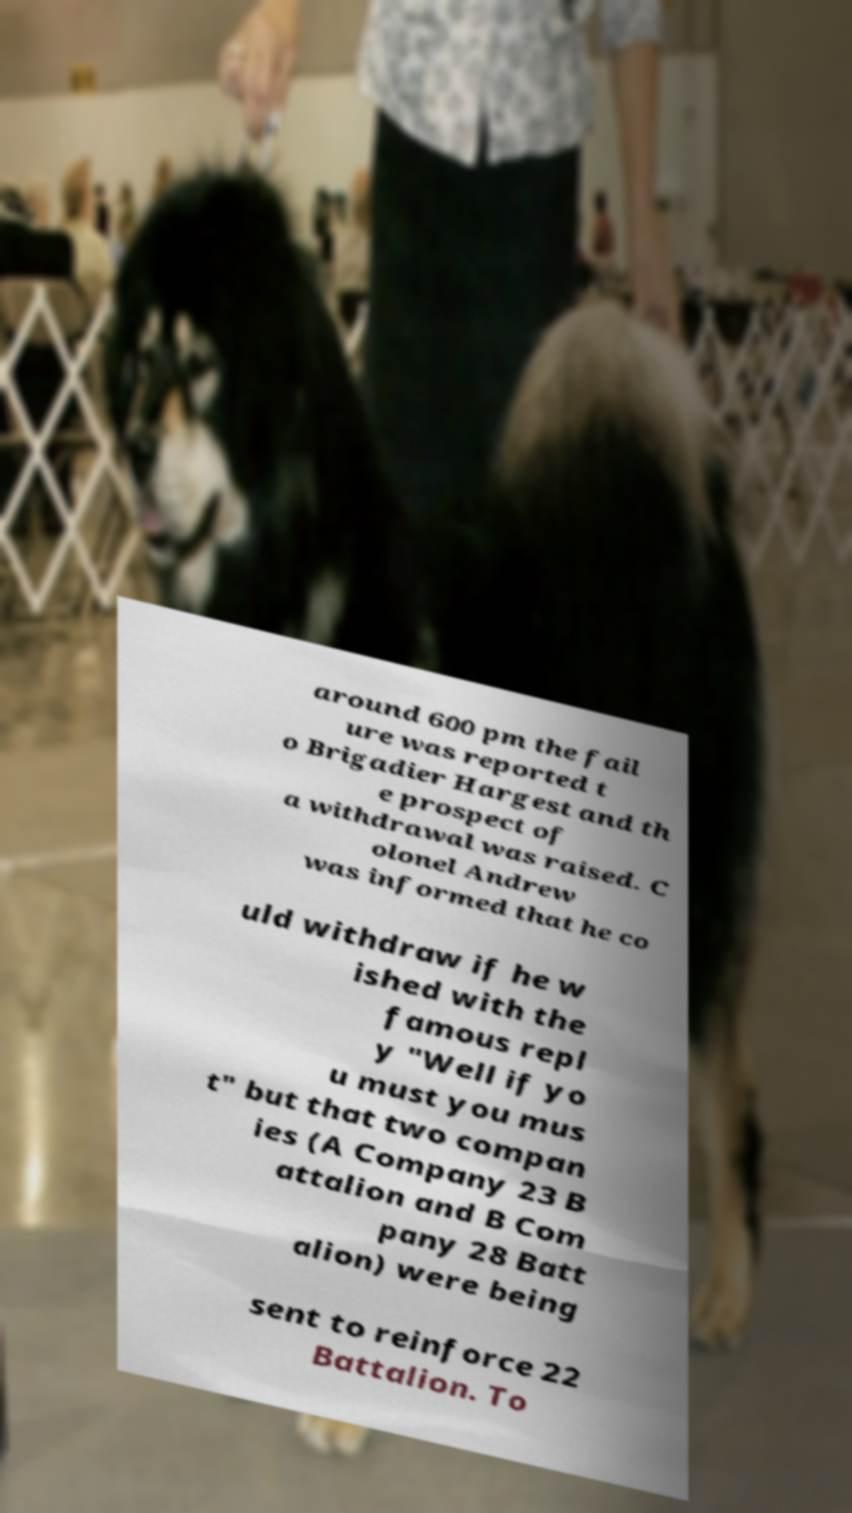Could you assist in decoding the text presented in this image and type it out clearly? around 600 pm the fail ure was reported t o Brigadier Hargest and th e prospect of a withdrawal was raised. C olonel Andrew was informed that he co uld withdraw if he w ished with the famous repl y "Well if yo u must you mus t" but that two compan ies (A Company 23 B attalion and B Com pany 28 Batt alion) were being sent to reinforce 22 Battalion. To 